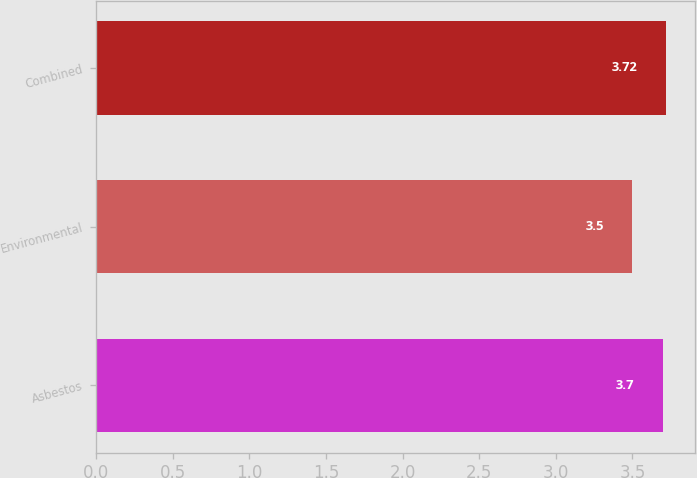<chart> <loc_0><loc_0><loc_500><loc_500><bar_chart><fcel>Asbestos<fcel>Environmental<fcel>Combined<nl><fcel>3.7<fcel>3.5<fcel>3.72<nl></chart> 